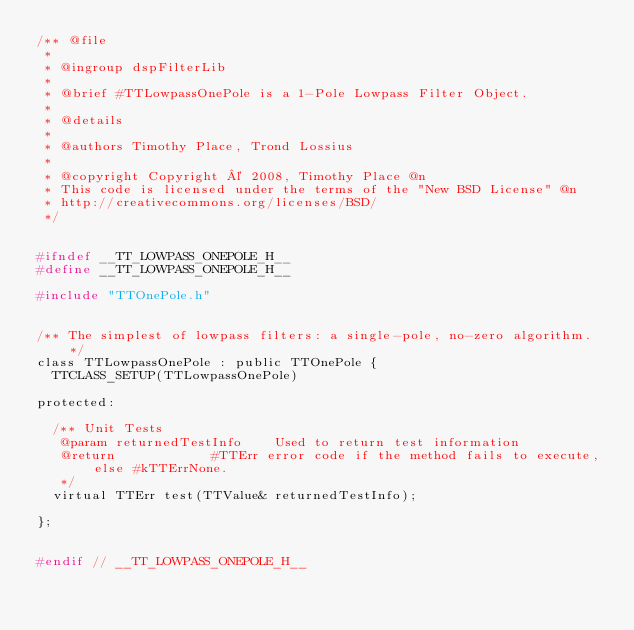Convert code to text. <code><loc_0><loc_0><loc_500><loc_500><_C_>/** @file
 *
 * @ingroup dspFilterLib
 *
 * @brief #TTLowpassOnePole is a 1-Pole Lowpass Filter Object.
 *
 * @details
 *
 * @authors Timothy Place, Trond Lossius
 *
 * @copyright Copyright © 2008, Timothy Place @n
 * This code is licensed under the terms of the "New BSD License" @n
 * http://creativecommons.org/licenses/BSD/
 */


#ifndef __TT_LOWPASS_ONEPOLE_H__
#define __TT_LOWPASS_ONEPOLE_H__

#include "TTOnePole.h"


/**	The simplest of lowpass filters: a single-pole, no-zero algorithm. */
class TTLowpassOnePole : public TTOnePole {
	TTCLASS_SETUP(TTLowpassOnePole)

protected:
	
	/**	Unit Tests
	 @param	returnedTestInfo		Used to return test information
	 @return						#TTErr error code if the method fails to execute, else #kTTErrNone.
	 */
	virtual TTErr test(TTValue& returnedTestInfo);
	
};


#endif // __TT_LOWPASS_ONEPOLE_H__
</code> 